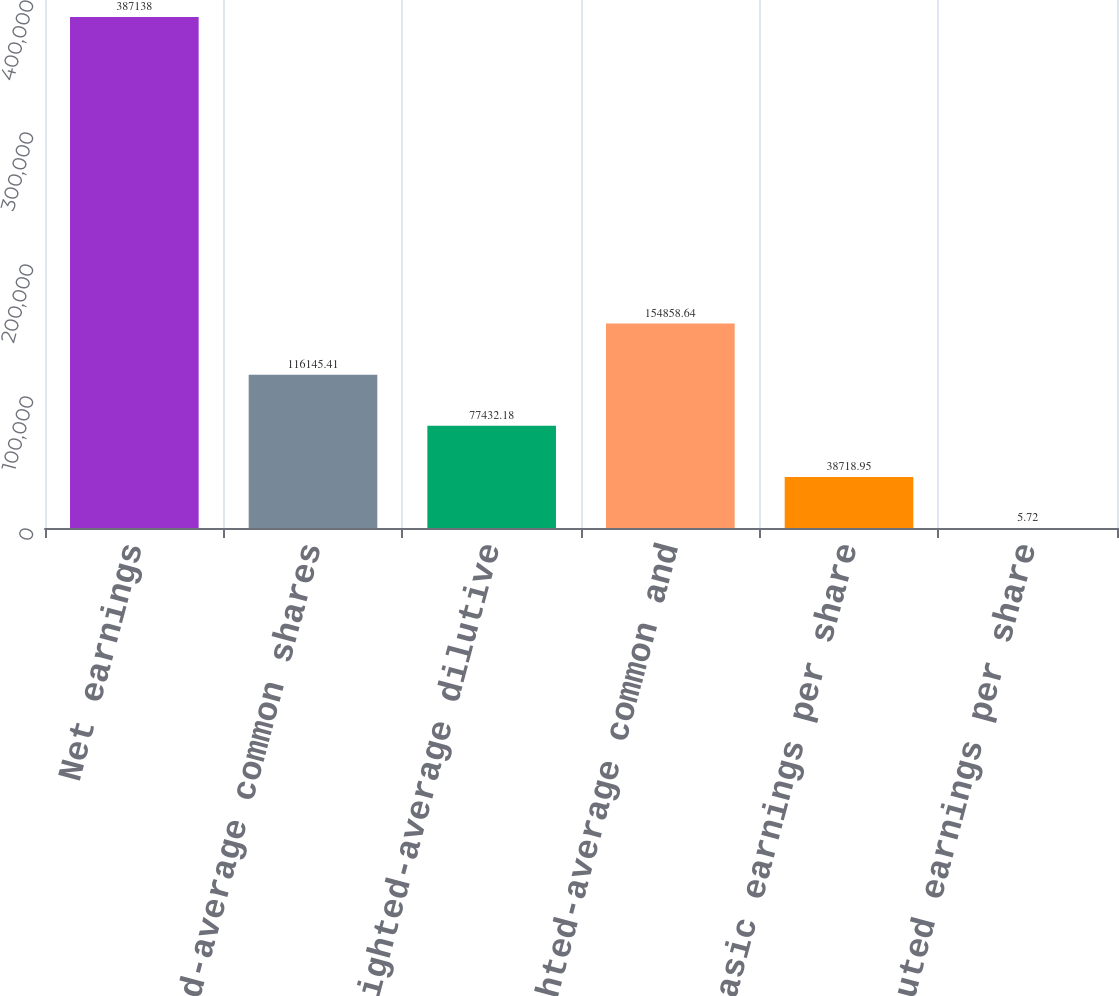<chart> <loc_0><loc_0><loc_500><loc_500><bar_chart><fcel>Net earnings<fcel>weighted-average common shares<fcel>Add weighted-average dilutive<fcel>weighted-average common and<fcel>Basic earnings per share<fcel>Diluted earnings per share<nl><fcel>387138<fcel>116145<fcel>77432.2<fcel>154859<fcel>38718.9<fcel>5.72<nl></chart> 